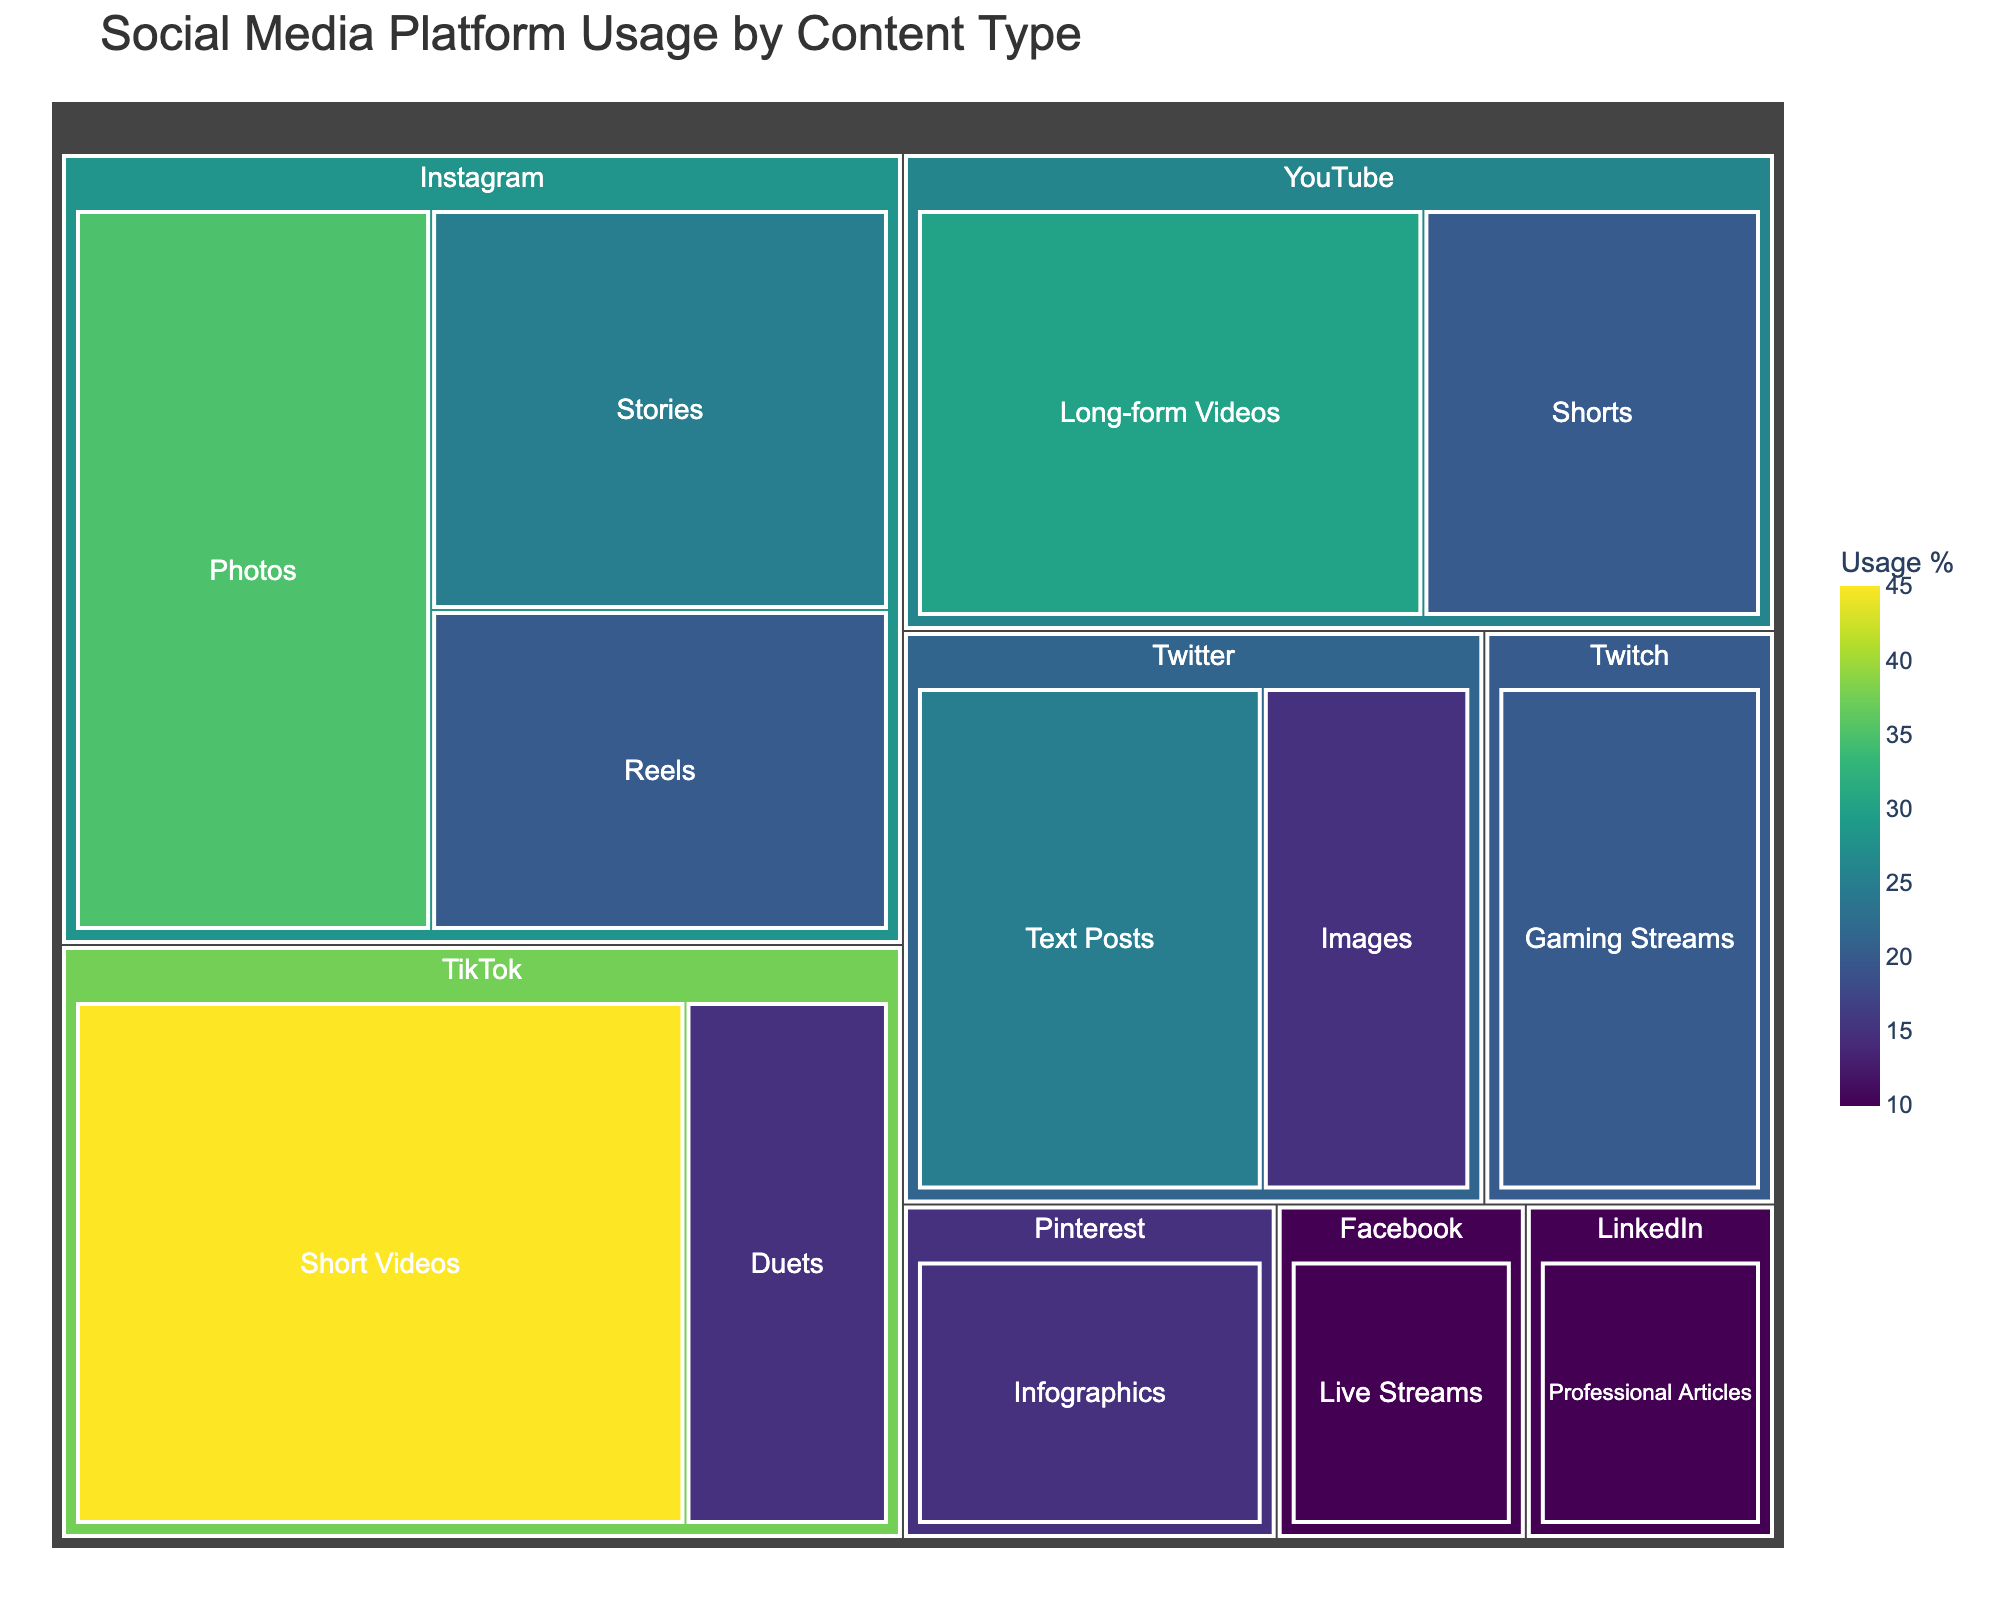What is the most used content type on TikTok according to the treemap? The treemap shows different content types and their usage percentages for each platform. The largest segment within TikTok should indicate the most used content type. The “Short Videos” segment on TikTok is the largest, indicating it's the most used.
Answer: Short Videos Which social media platform is associated with the content type "Gaming Streams"? The content types are categorized under their respective platforms in the treemap. Find and locate the "Gaming Streams" content type and trace it to its parent category. It belongs to Twitch.
Answer: Twitch What is the combined usage percentage for Instagram's "Photos" and "Stories"? Locate the "Photos" and "Stories" segments under Instagram and sum their usage percentages. Photos have 35% and Stories have 25%, so the sum is 35 + 25 = 60%.
Answer: 60% Which content type has the lowest usage percentage and on which platform is it found? Identify the smallest segment on the treemap. “Live Streams” on Facebook has the smallest usage at 10%.
Answer: Live Streams on Facebook Compare the usage of "Long-form Videos" on YouTube with "Text Posts" on Twitter. Which one is higher? Find the segments for "Long-form Videos" on YouTube and "Text Posts" on Twitter. "Long-form Videos" has 30% and "Text Posts" has 25%. Therefore, the usage for Long-form Videos is higher.
Answer: Long-form Videos How much more popular is TikTok’s "Short Videos" compared to Instagram’s "Reels"? Find the segments for TikTok’s "Short Videos" and Instagram’s "Reels". "Short Videos" has 45% and "Reels" has 20%. The difference is 45% - 20% = 25%.
Answer: 25% more Which platform has the widest variety of content types shown in the treemap? Count the number of different content types under each platform in the treemap. Instagram has Photos, Stories, and Reels (3 content types).
Answer: Instagram What's the total usage percentage for all content types in Twitter? Sum the usage percentages for all content types under Twitter. Text Posts have 25% and Images have 15%, so the total is 25 + 15 = 40%.
Answer: 40% What is the least used content type on Instagram according to the treemap? Look under Instagram and identify the segment with the smallest value. "Reels" have the smallest usage percentage at 20%.
Answer: Reels What's the difference in usage percentage between TikTok's "Duets" and Pinterest's "Infographics"? Locate TikTok’s "Duets" and Pinterest’s "Infographics". "Duets" have 15% and "Infographics" have 15%. The difference is 15% - 15% = 0%.
Answer: 0% 